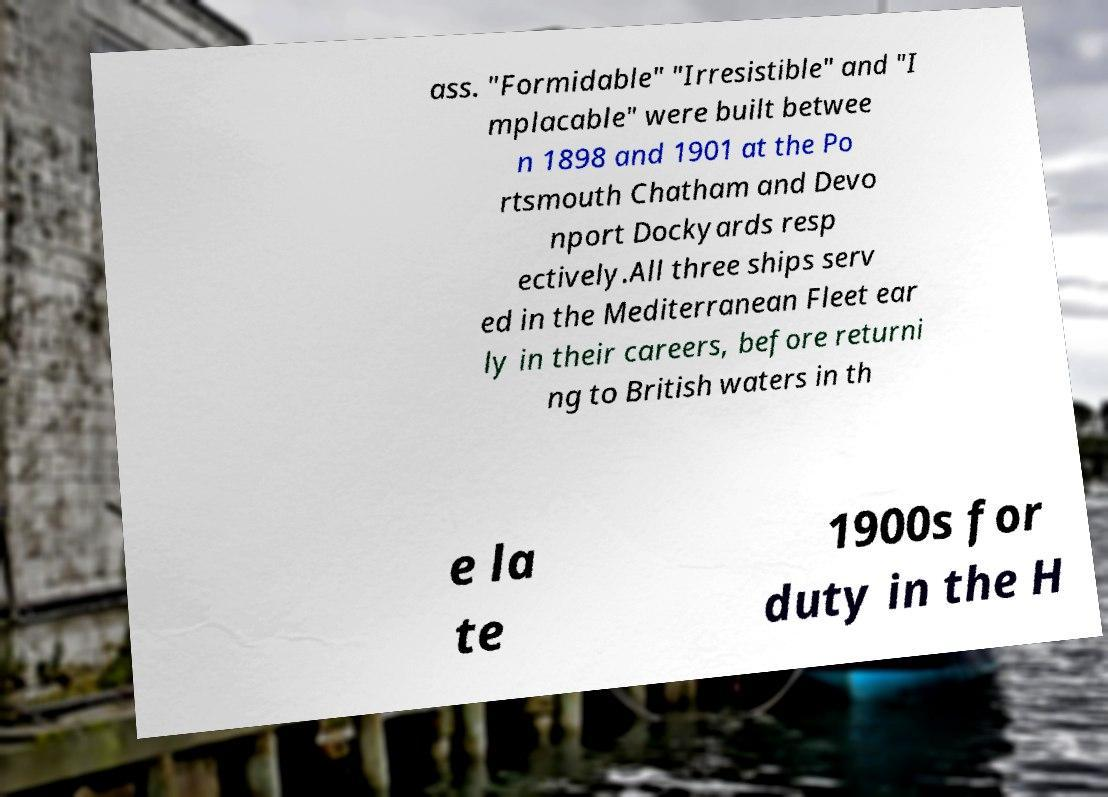Could you extract and type out the text from this image? ass. "Formidable" "Irresistible" and "I mplacable" were built betwee n 1898 and 1901 at the Po rtsmouth Chatham and Devo nport Dockyards resp ectively.All three ships serv ed in the Mediterranean Fleet ear ly in their careers, before returni ng to British waters in th e la te 1900s for duty in the H 